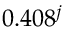<formula> <loc_0><loc_0><loc_500><loc_500>0 . 4 0 8 ^ { j }</formula> 